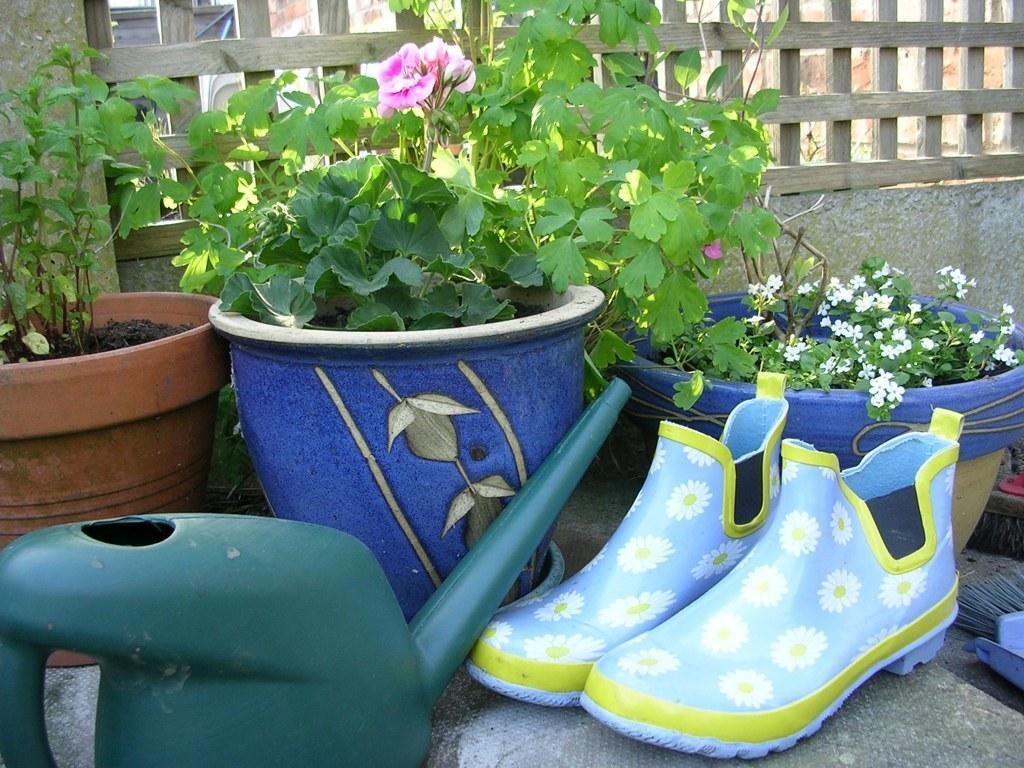How would you summarize this image in a sentence or two? In this picture I can see the pair of shoe which is kept near to the pots. On the pot I can see the flowers and plants. In the bottom left corner there is a water sprinkler box. At the top I can see the wooden fencing. In the background I can see the building and other object. 